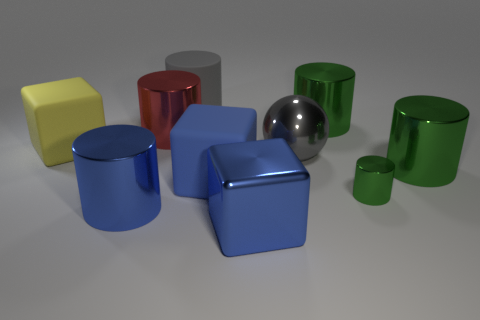Are there any patterns or themes to the arrangement of these objects? The objects are arranged seemingly at random, yet the assortment of geometric shapes and varying colors suggests a theme exploring the diversity of simple 3D forms and hues.  Can you tell me which objects have flat surfaces? Certainly, the cubes and the rectangular prism have flat surfaces. Their edges are sharply defined, creating planes that meet at distinct angles. 